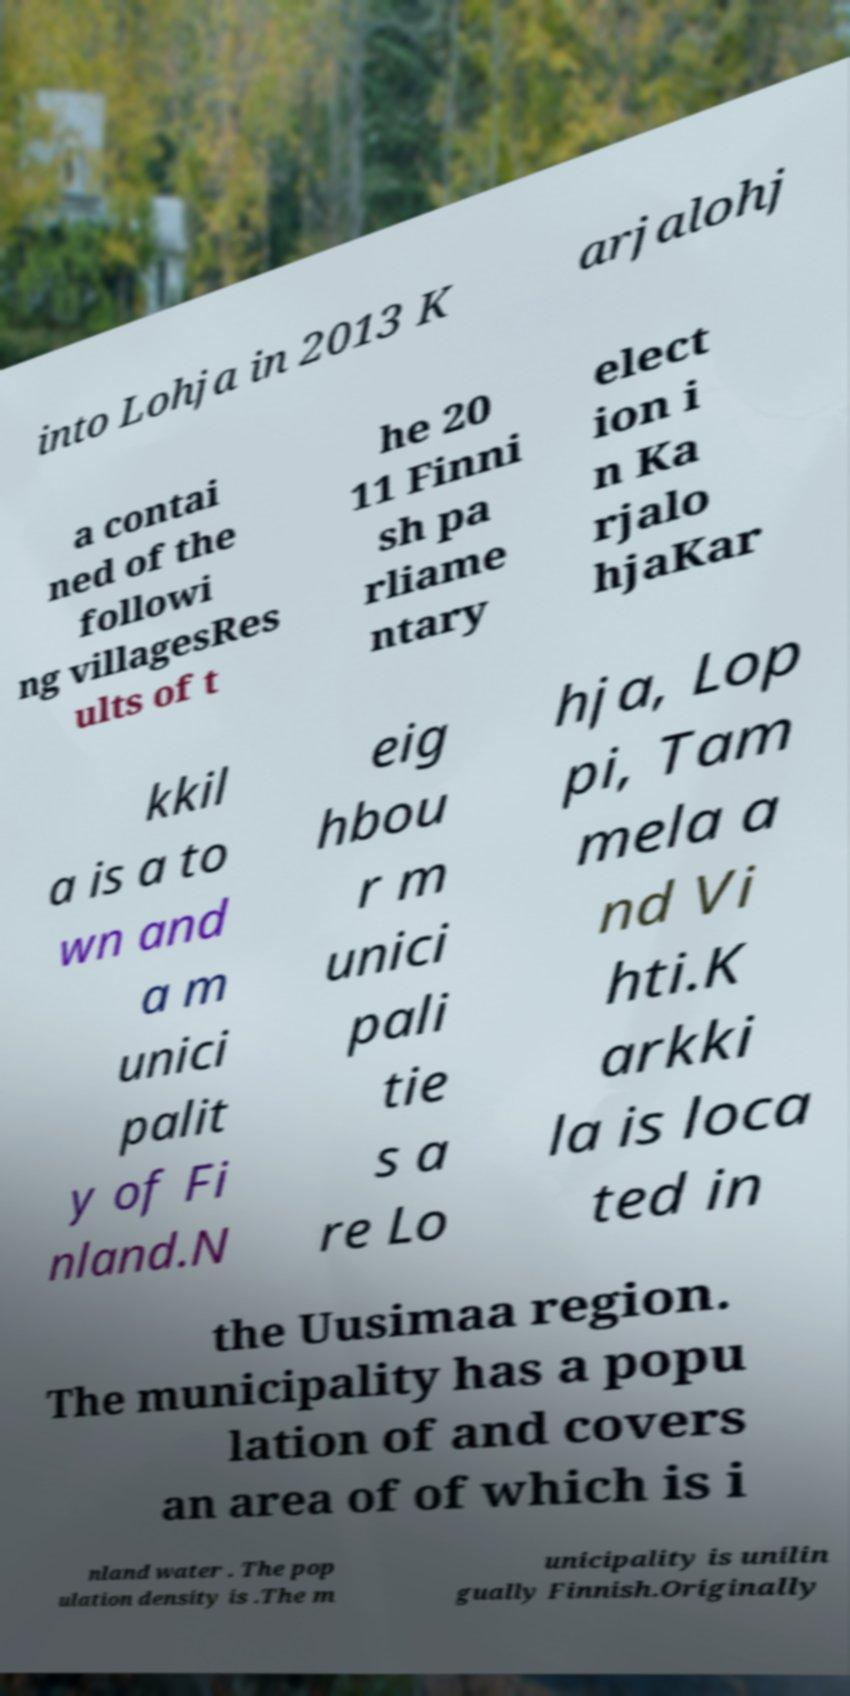Could you assist in decoding the text presented in this image and type it out clearly? into Lohja in 2013 K arjalohj a contai ned of the followi ng villagesRes ults of t he 20 11 Finni sh pa rliame ntary elect ion i n Ka rjalo hjaKar kkil a is a to wn and a m unici palit y of Fi nland.N eig hbou r m unici pali tie s a re Lo hja, Lop pi, Tam mela a nd Vi hti.K arkki la is loca ted in the Uusimaa region. The municipality has a popu lation of and covers an area of of which is i nland water . The pop ulation density is .The m unicipality is unilin gually Finnish.Originally 